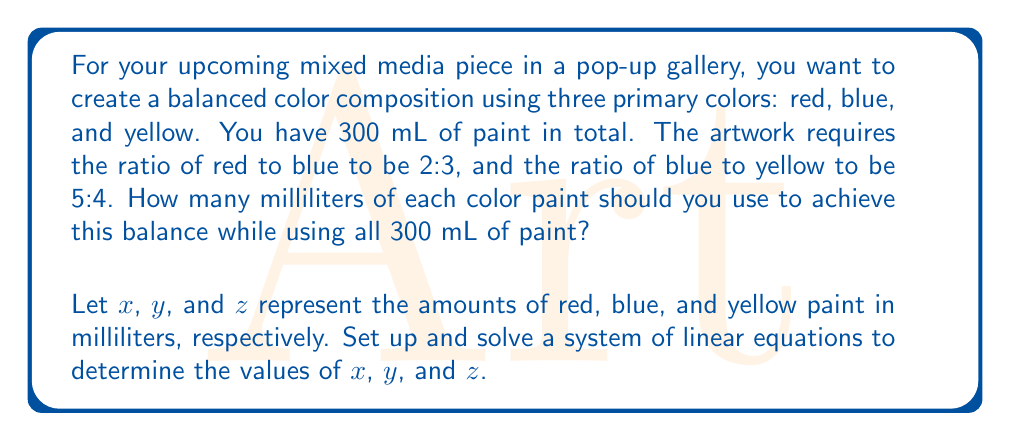Show me your answer to this math problem. Let's approach this step-by-step:

1) First, we need to set up our system of linear equations based on the given information:

   Equation 1: Total amount of paint
   $$x + y + z = 300$$

   Equation 2: Ratio of red to blue (2:3)
   $$\frac{x}{y} = \frac{2}{3}$$ or $$3x - 2y = 0$$

   Equation 3: Ratio of blue to yellow (5:4)
   $$\frac{y}{z} = \frac{5}{4}$$ or $$4y - 5z = 0$$

2) Now we have a system of three linear equations:
   $$\begin{cases}
   x + y + z = 300 \\
   3x - 2y = 0 \\
   4y - 5z = 0
   \end{cases}$$

3) From the second equation:
   $$3x - 2y = 0$$
   $$3x = 2y$$
   $$x = \frac{2y}{3}$$

4) From the third equation:
   $$4y - 5z = 0$$
   $$4y = 5z$$
   $$y = \frac{5z}{4}$$

5) Substitute these into the first equation:
   $$\frac{2y}{3} + y + z = 300$$
   $$\frac{2(\frac{5z}{4})}{3} + \frac{5z}{4} + z = 300$$
   $$\frac{10z}{12} + \frac{15z}{12} + \frac{12z}{12} = 300$$
   $$\frac{37z}{12} = 300$$
   $$z = \frac{300 * 12}{37} = 97.297...$$

6) Round to the nearest milliliter:
   $$z = 97 \text{ mL}$$

7) Now we can find y:
   $$y = \frac{5z}{4} = \frac{5 * 97}{4} = 121.25 \approx 121 \text{ mL}$$

8) And finally, x:
   $$x = 300 - y - z = 300 - 121 - 97 = 82 \text{ mL}$$
Answer: Red (x): 82 mL
Blue (y): 121 mL
Yellow (z): 97 mL 